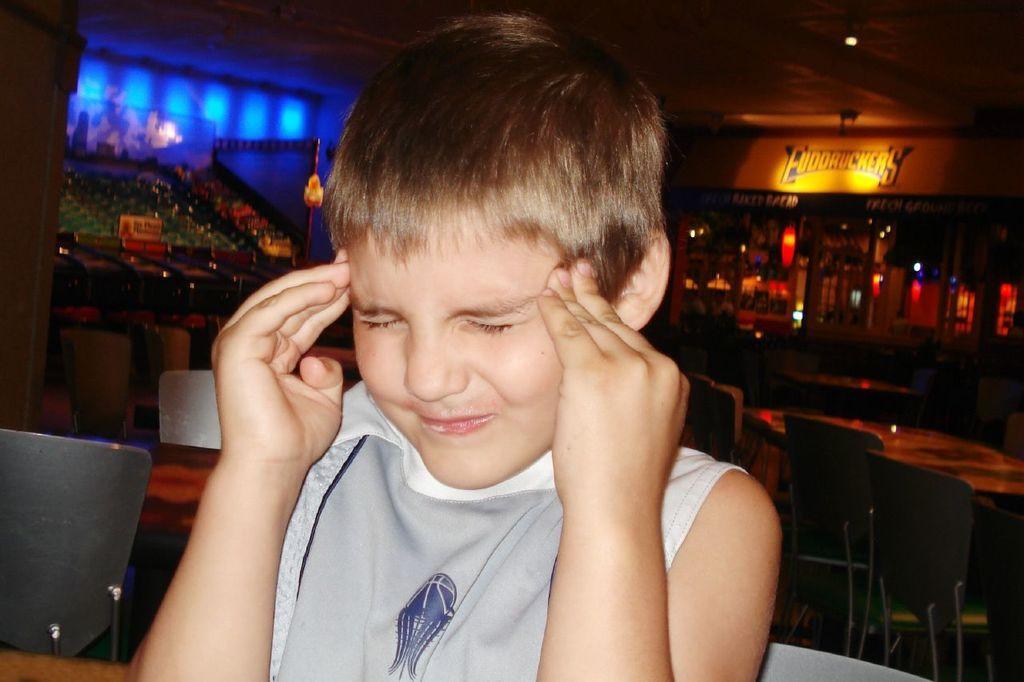Can you describe this image briefly? This image is taken indoors. In this image the background is a little dark. There are a few lights. There is a board with a text on it. There are a few objects and there are many empty chairs and tables. In the middle of the image there is a kid sitting on the chair. 